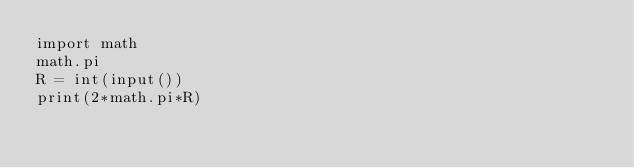<code> <loc_0><loc_0><loc_500><loc_500><_Python_>import math
math.pi
R = int(input())
print(2*math.pi*R)</code> 